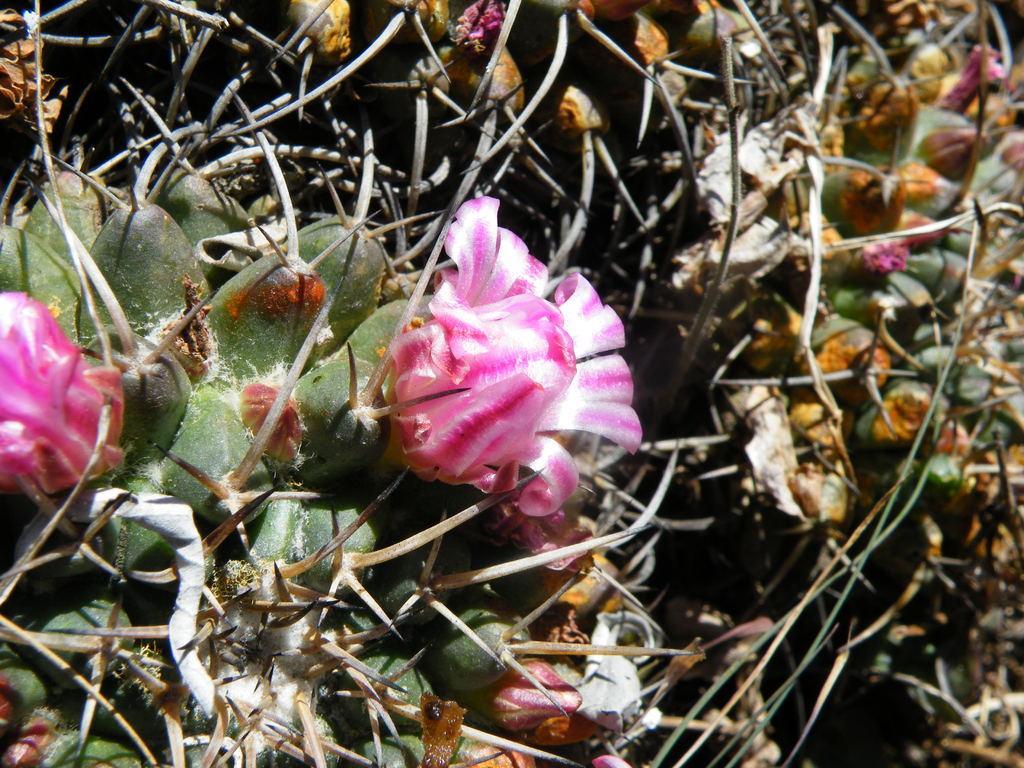How would you summarize this image in a sentence or two? In this image I can see few pink and white color flower and I can see few green color plants. 